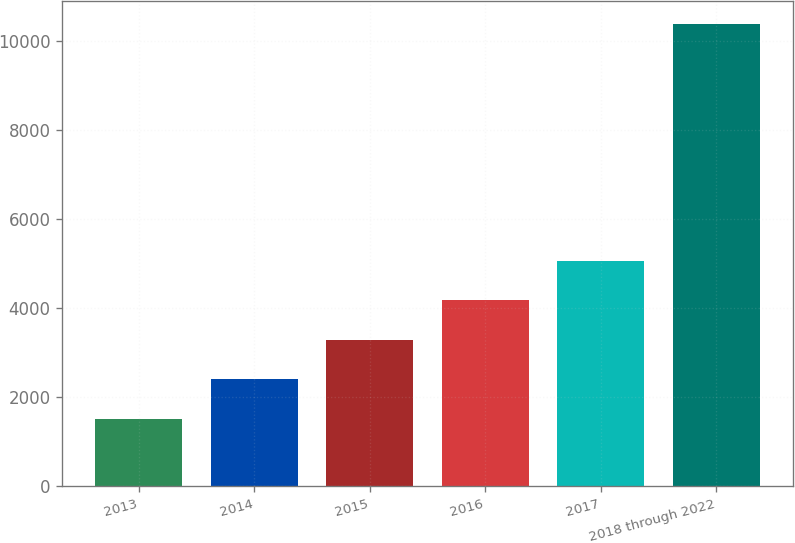Convert chart to OTSL. <chart><loc_0><loc_0><loc_500><loc_500><bar_chart><fcel>2013<fcel>2014<fcel>2015<fcel>2016<fcel>2017<fcel>2018 through 2022<nl><fcel>1510<fcel>2397.1<fcel>3284.2<fcel>4171.3<fcel>5058.4<fcel>10381<nl></chart> 